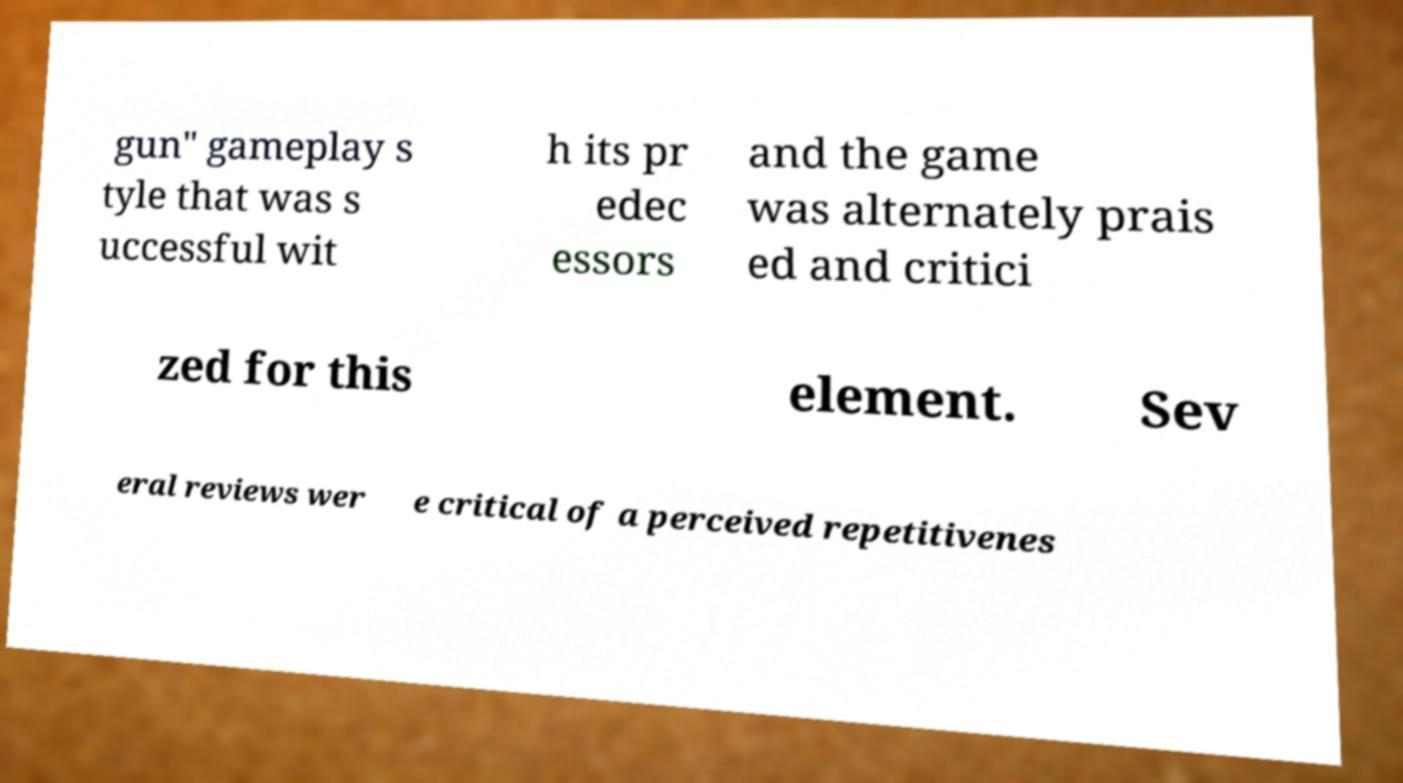Please read and relay the text visible in this image. What does it say? gun" gameplay s tyle that was s uccessful wit h its pr edec essors and the game was alternately prais ed and critici zed for this element. Sev eral reviews wer e critical of a perceived repetitivenes 